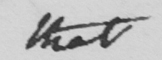What does this handwritten line say? that 